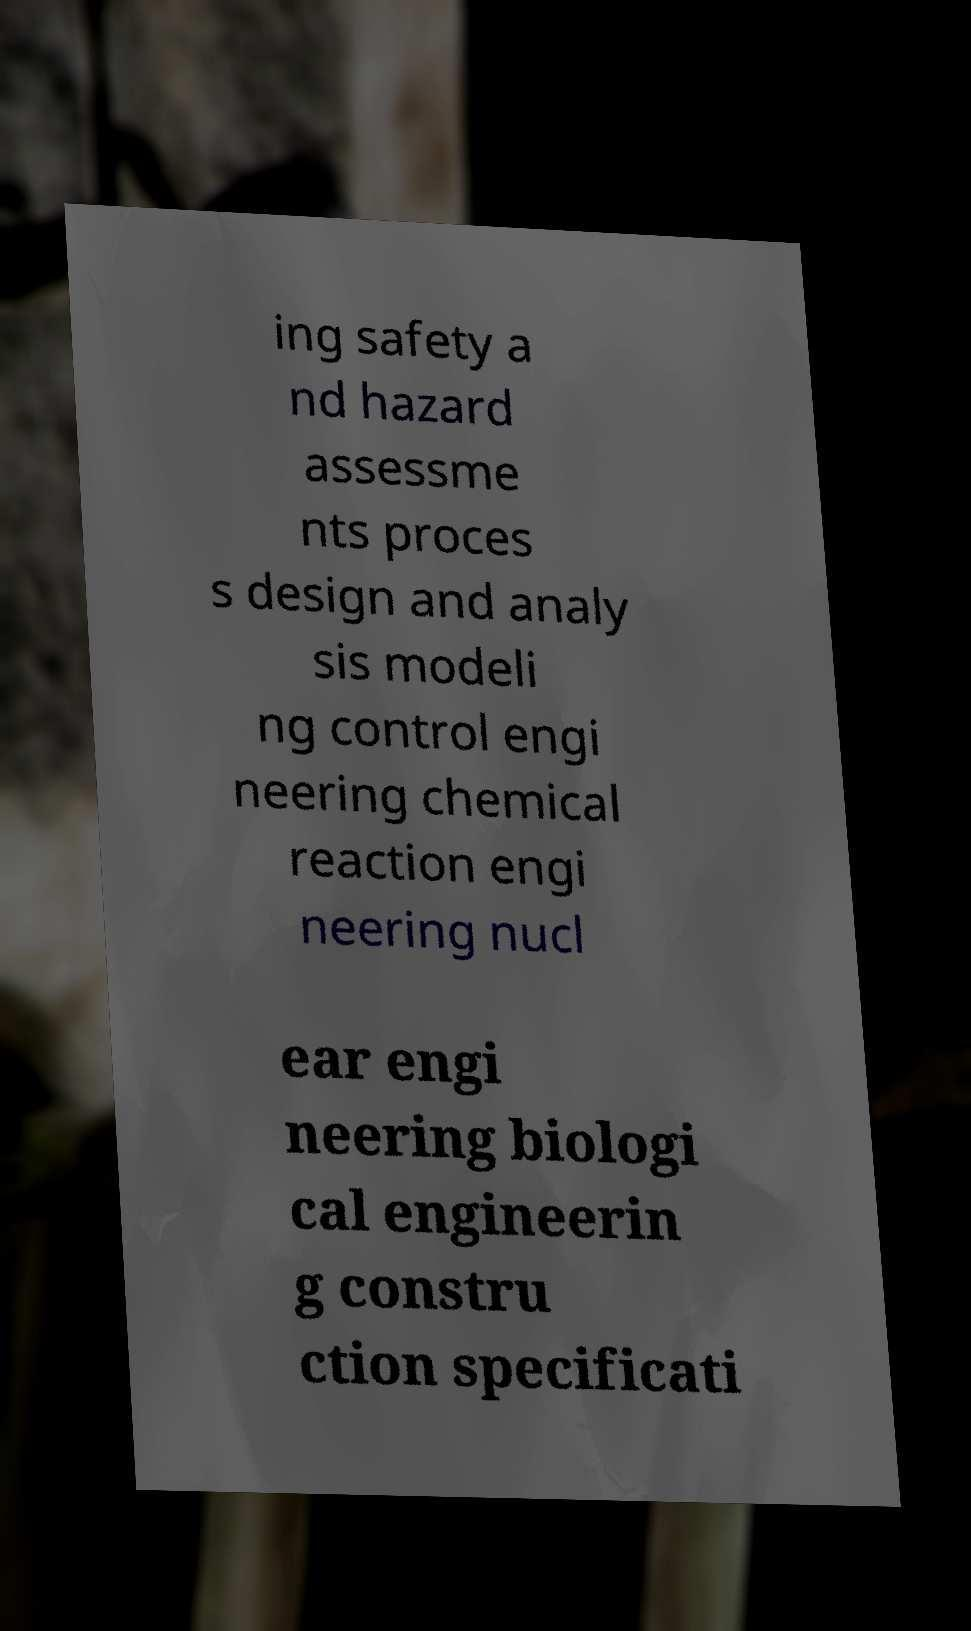What messages or text are displayed in this image? I need them in a readable, typed format. ing safety a nd hazard assessme nts proces s design and analy sis modeli ng control engi neering chemical reaction engi neering nucl ear engi neering biologi cal engineerin g constru ction specificati 